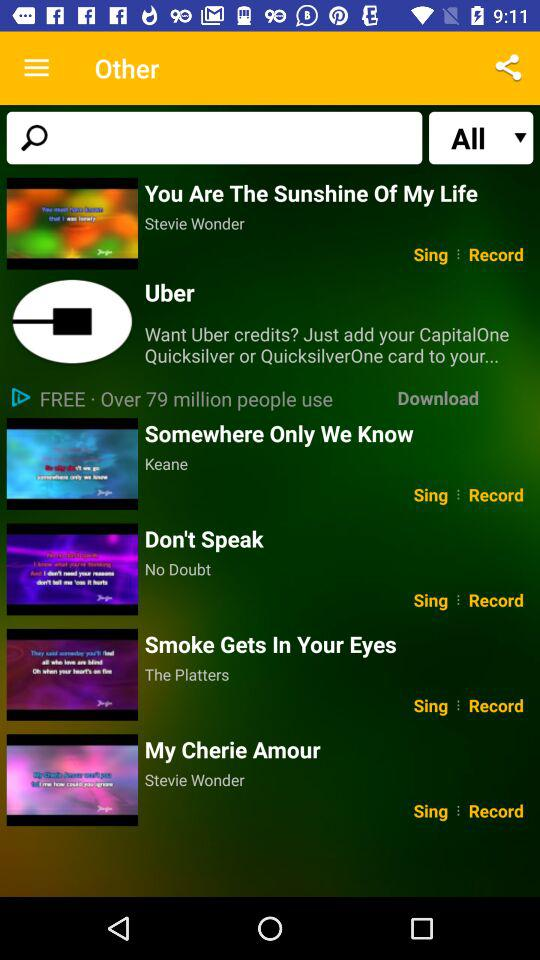Which type of application is used in?
When the provided information is insufficient, respond with <no answer>. <no answer> 